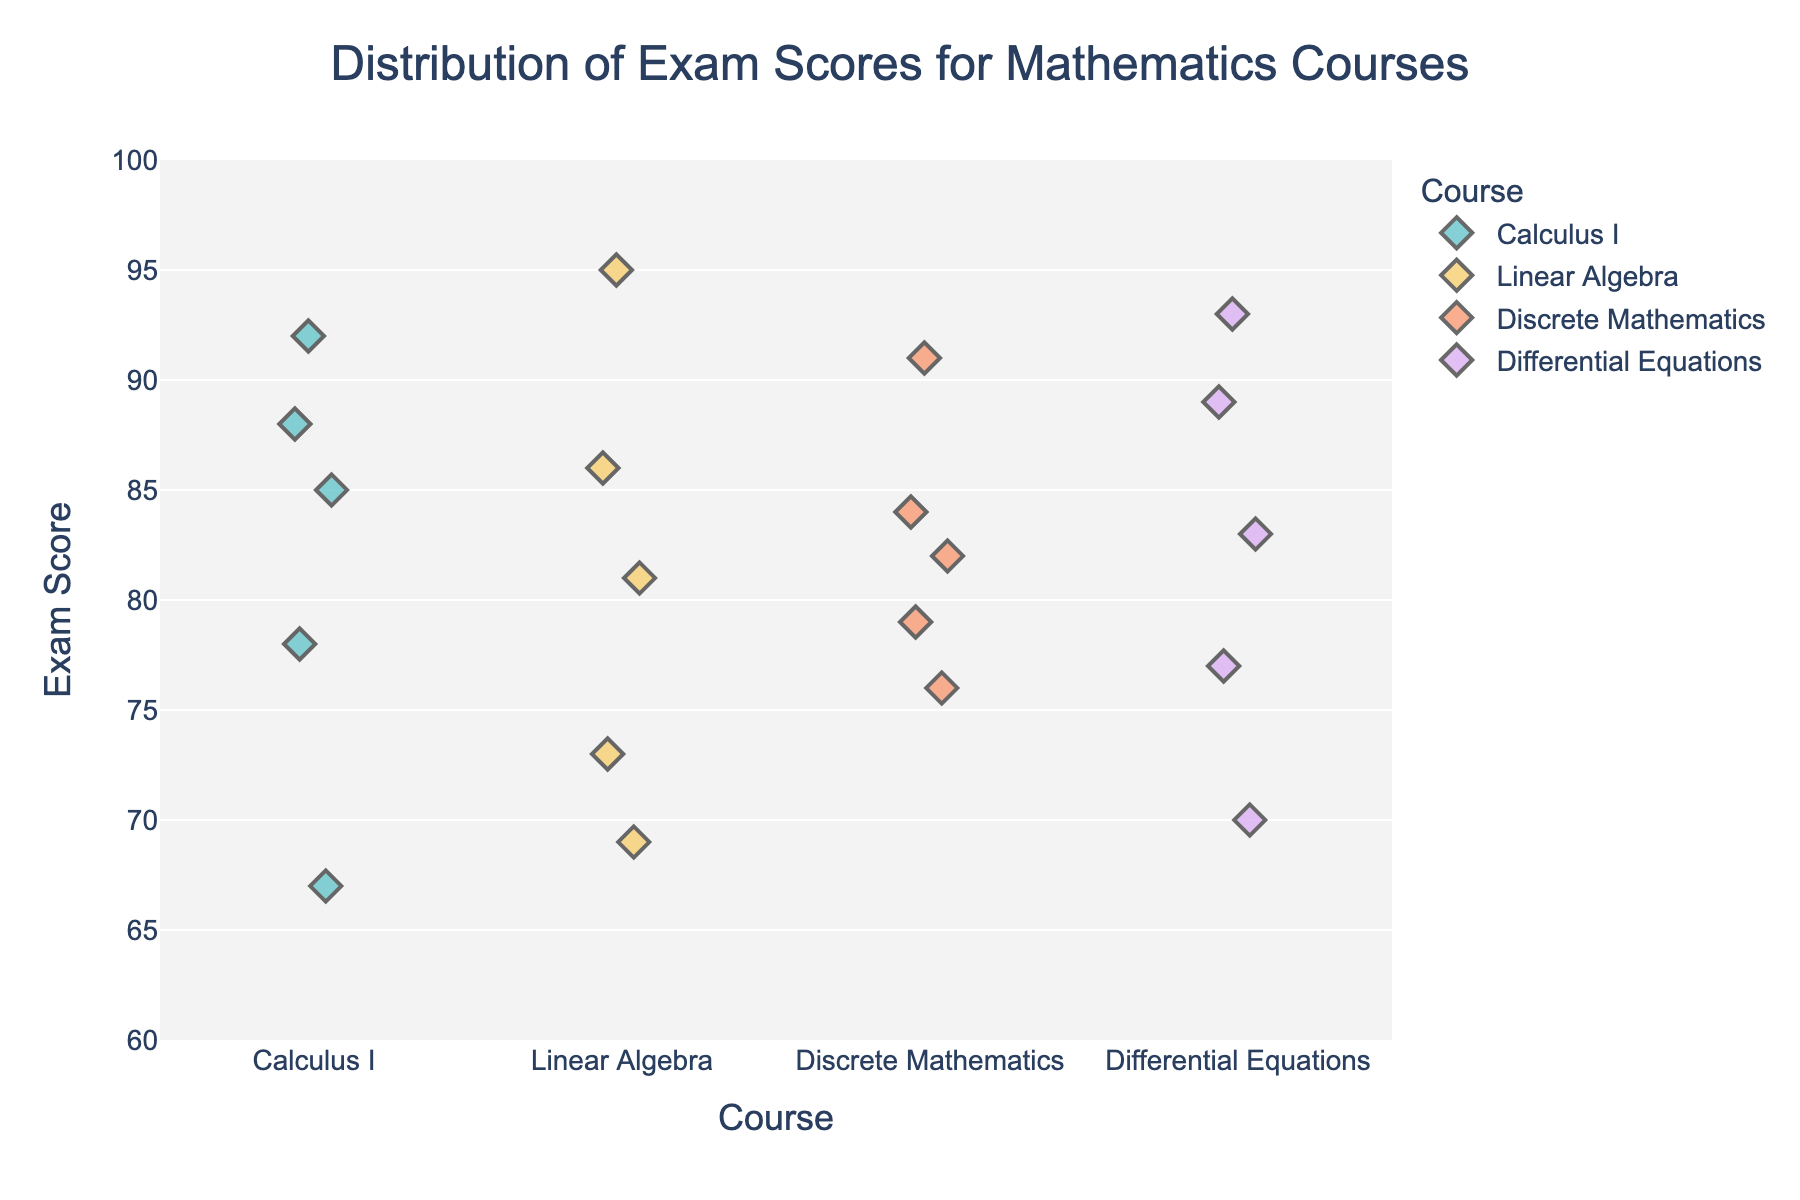What is the title of the figure? The title of the figure is located at the top of the plot.
Answer: Distribution of Exam Scores for Mathematics Courses How many different mathematics courses are represented in the plot? The x-axis labels show each distinct course. These are: Calculus I, Linear Algebra, Discrete Mathematics, and Differential Equations.
Answer: 4 Which course has the highest exam score? Look at the strip plot and identify the highest point on the y-axis, then check the corresponding course on the x-axis.
Answer: Linear Algebra What is the range of scores for Calculus I? The range is the difference between the maximum and minimum scores for Calculus I points on the y-axis. Maximum is 92, and minimum is 67.
Answer: 25 Which course has the most tightly clustered exam scores? Compare the spread of data points vertically for each course. The course with the smallest vertical spread of points has the most tightly clustered scores.
Answer: Discrete Mathematics What is the average score for Differential Equations? Add up all the scores for Differential Equations, then divide by the number of scores: (70+89+77+93+83)/5.
Answer: 82.4 Between Calculus I and Discrete Mathematics, which has a higher median score? Arrange the exam scores of each course in order and find the middle value. Median for Calculus I is 85; Median for Discrete Mathematics is 82.
Answer: Calculus I Compare the maximum scores of Linear Algebra and Discrete Mathematics. Are they equal? Identify the highest points for both courses on the y-axis. Both maximums are 95 and 91 respectively.
Answer: No What is the difference in scores between the highest and lowest points for Linear Algebra? Subtract the lowest score from the highest score for Linear Algebra. Highest is 95, and lowest is 69.
Answer: 26 For which course is there a score that is closest to 80? Look at the scores for each course and find the score closest to 80.
Answer: Linear Algebra 